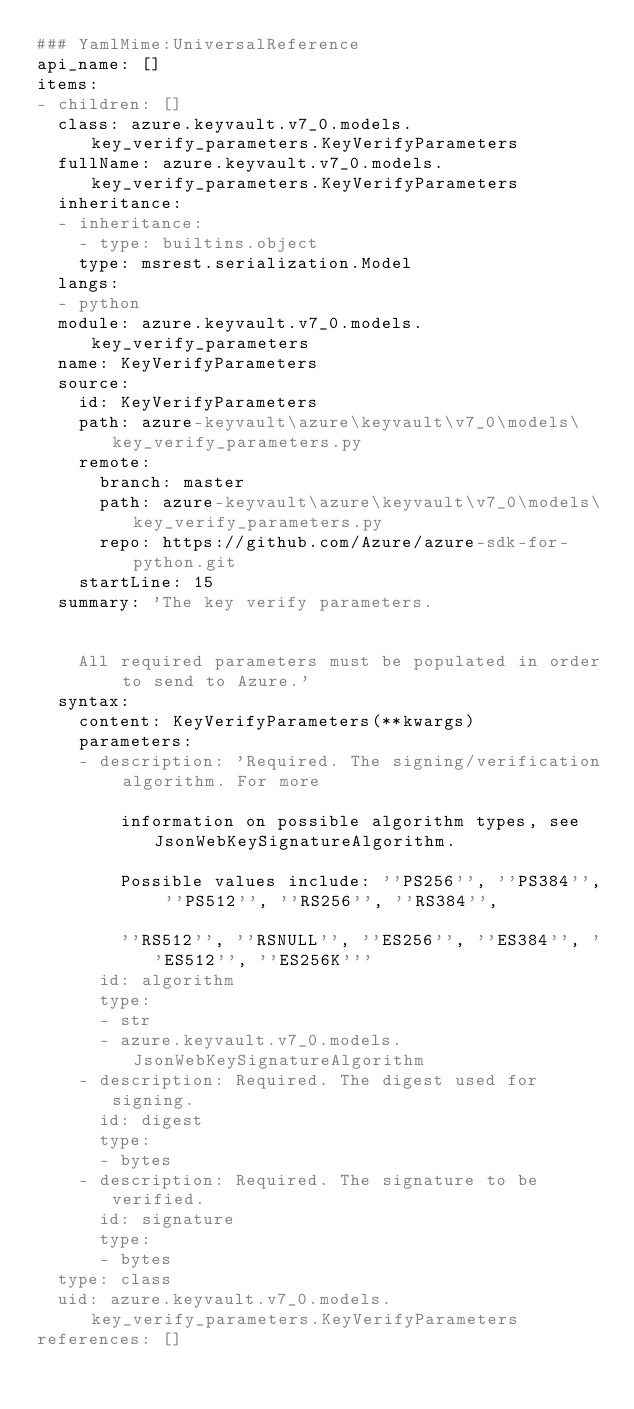Convert code to text. <code><loc_0><loc_0><loc_500><loc_500><_YAML_>### YamlMime:UniversalReference
api_name: []
items:
- children: []
  class: azure.keyvault.v7_0.models.key_verify_parameters.KeyVerifyParameters
  fullName: azure.keyvault.v7_0.models.key_verify_parameters.KeyVerifyParameters
  inheritance:
  - inheritance:
    - type: builtins.object
    type: msrest.serialization.Model
  langs:
  - python
  module: azure.keyvault.v7_0.models.key_verify_parameters
  name: KeyVerifyParameters
  source:
    id: KeyVerifyParameters
    path: azure-keyvault\azure\keyvault\v7_0\models\key_verify_parameters.py
    remote:
      branch: master
      path: azure-keyvault\azure\keyvault\v7_0\models\key_verify_parameters.py
      repo: https://github.com/Azure/azure-sdk-for-python.git
    startLine: 15
  summary: 'The key verify parameters.


    All required parameters must be populated in order to send to Azure.'
  syntax:
    content: KeyVerifyParameters(**kwargs)
    parameters:
    - description: 'Required. The signing/verification algorithm. For more

        information on possible algorithm types, see JsonWebKeySignatureAlgorithm.

        Possible values include: ''PS256'', ''PS384'', ''PS512'', ''RS256'', ''RS384'',

        ''RS512'', ''RSNULL'', ''ES256'', ''ES384'', ''ES512'', ''ES256K'''
      id: algorithm
      type:
      - str
      - azure.keyvault.v7_0.models.JsonWebKeySignatureAlgorithm
    - description: Required. The digest used for signing.
      id: digest
      type:
      - bytes
    - description: Required. The signature to be verified.
      id: signature
      type:
      - bytes
  type: class
  uid: azure.keyvault.v7_0.models.key_verify_parameters.KeyVerifyParameters
references: []
</code> 